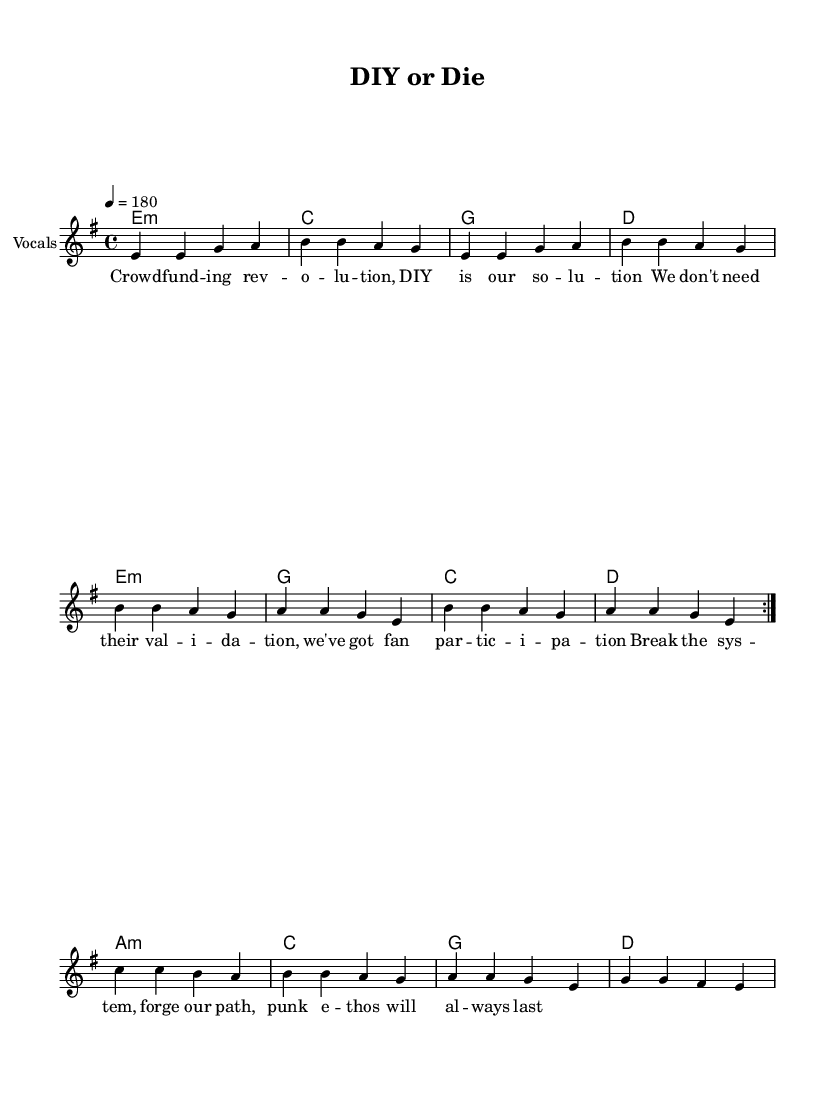What is the key signature of this music? The key signature is e minor, which has one sharp (F#). This can be identified by looking at the key signature notation at the beginning of the staff.
Answer: e minor What is the time signature of the piece? The time signature is 4/4, which means there are four beats in each measure and the quarter note gets one beat. This is indicated at the start of the score.
Answer: 4/4 What is the tempo marking for this piece? The tempo marking is 180 BPM, indicated as "4 = 180" at the beginning of the score. This indicates the speed of the piece.
Answer: 180 How many times is the main melody repeated? The main melody is repeated twice, as indicated by the "volta 2" marking, which shows that the section is to be played two times.
Answer: 2 What is the last chord of the harmonies section? The last chord of the harmonies is D major, which can be identified by the chord notation at the end of the harmonies. It is the chord that follows the last measure.
Answer: D What lyrical theme does the piece convey overall? The lyrical theme revolves around DIY ethos and empowerment in the face of traditional music industry validation, as expressed directly in the lyrics. This reflects typical punk ideology advocating for independence and self-sufficiency.
Answer: DIY ethos What is the structure of the lyrics in the piece? The lyrics are structured with a repeated focus on community and self-empowerment, typical of punk songs that often emphasize collective action and rebellion against the status quo as seen in the lyrical content.
Answer: Repetitive community focus 